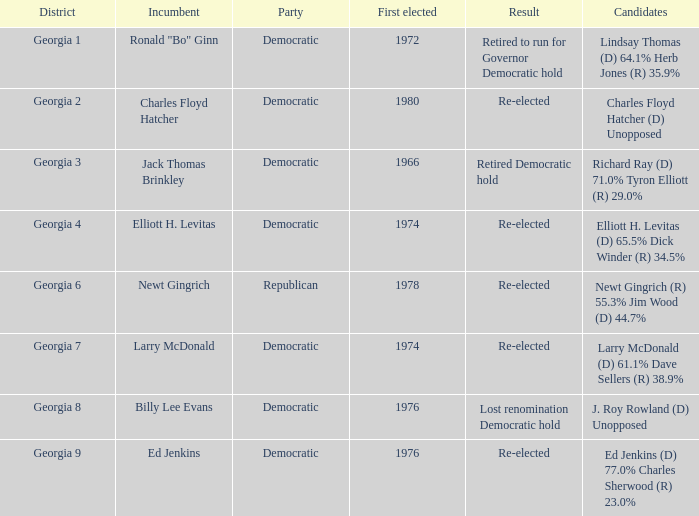Identify the celebration for jack thomas brinkley Democratic. 